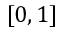Convert formula to latex. <formula><loc_0><loc_0><loc_500><loc_500>[ 0 , 1 ]</formula> 